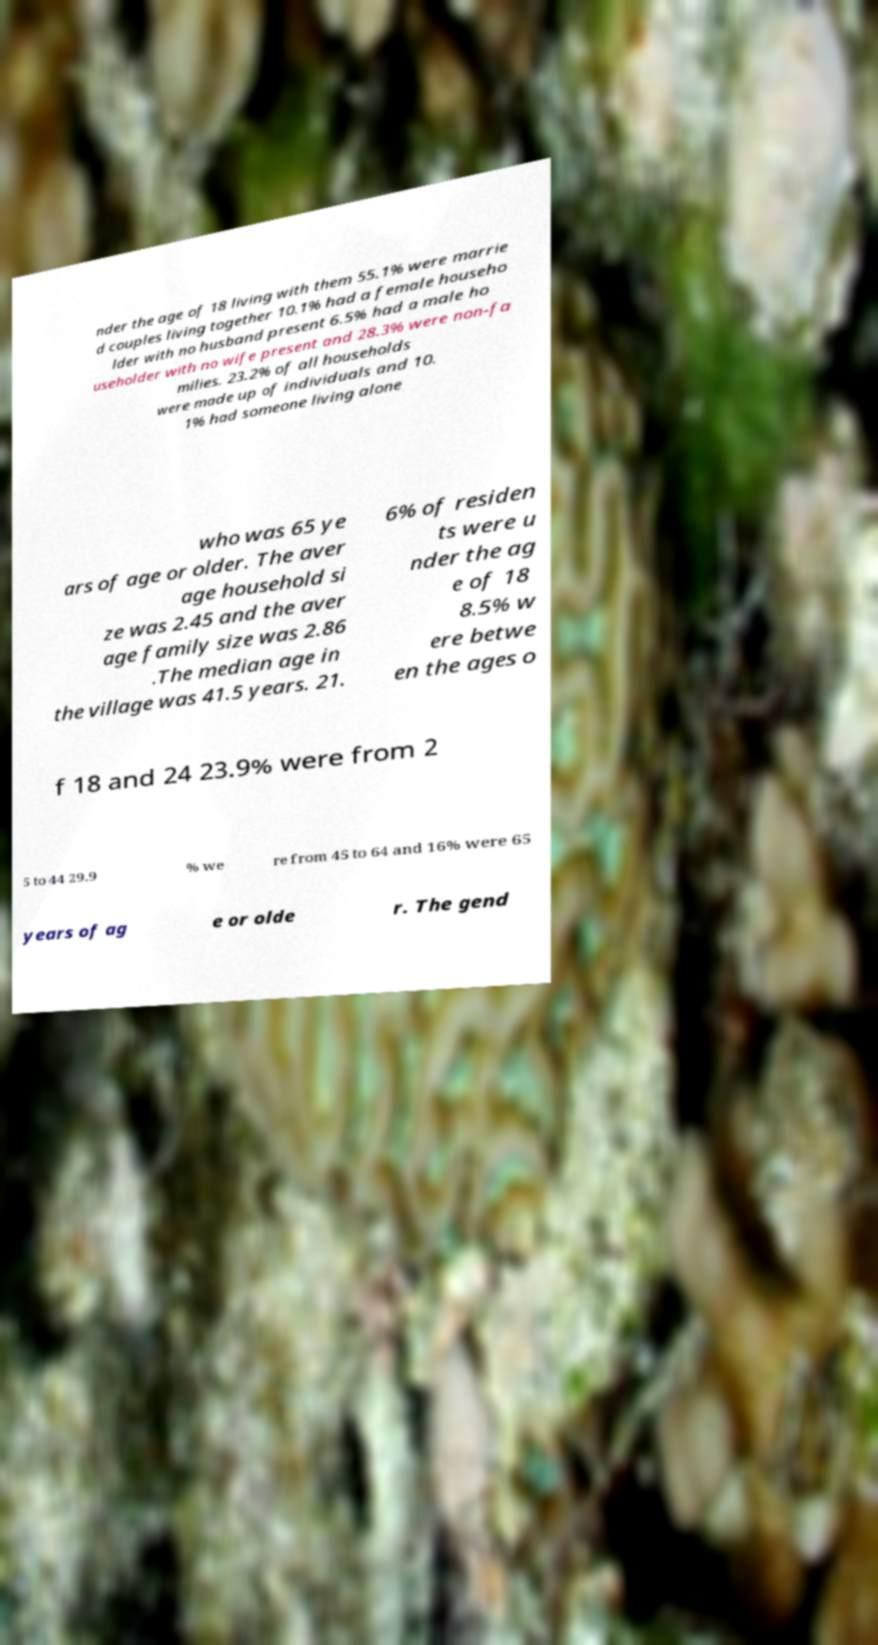I need the written content from this picture converted into text. Can you do that? nder the age of 18 living with them 55.1% were marrie d couples living together 10.1% had a female househo lder with no husband present 6.5% had a male ho useholder with no wife present and 28.3% were non-fa milies. 23.2% of all households were made up of individuals and 10. 1% had someone living alone who was 65 ye ars of age or older. The aver age household si ze was 2.45 and the aver age family size was 2.86 .The median age in the village was 41.5 years. 21. 6% of residen ts were u nder the ag e of 18 8.5% w ere betwe en the ages o f 18 and 24 23.9% were from 2 5 to 44 29.9 % we re from 45 to 64 and 16% were 65 years of ag e or olde r. The gend 